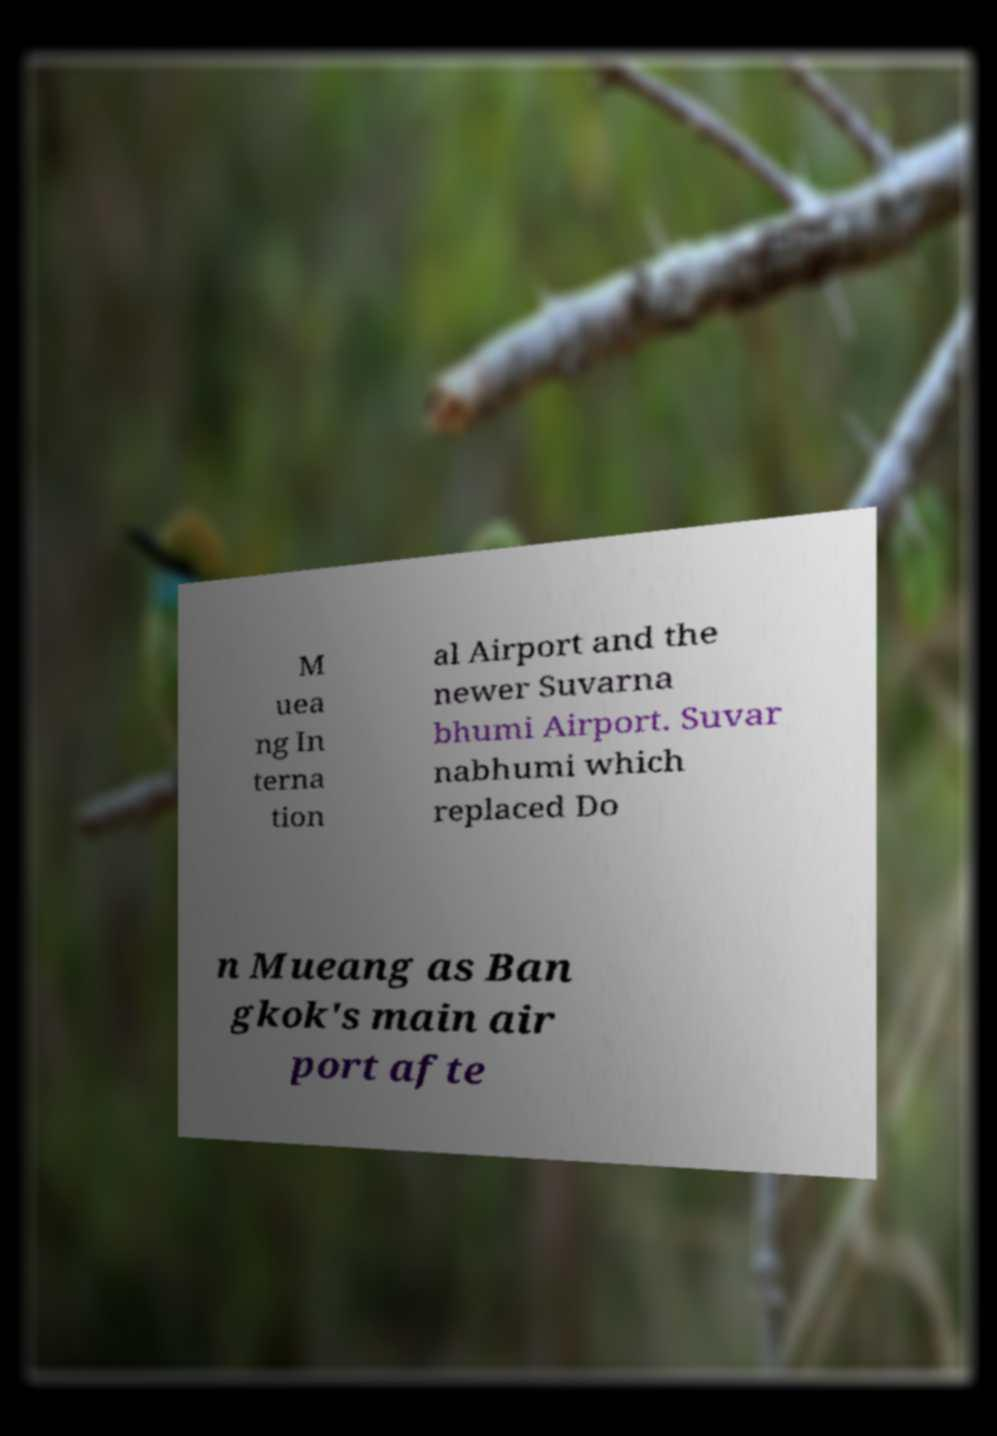Can you accurately transcribe the text from the provided image for me? M uea ng In terna tion al Airport and the newer Suvarna bhumi Airport. Suvar nabhumi which replaced Do n Mueang as Ban gkok's main air port afte 